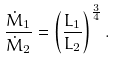<formula> <loc_0><loc_0><loc_500><loc_500>\frac { \dot { M } _ { 1 } } { \dot { M } _ { 2 } } = \left ( \frac { L _ { 1 } } { L _ { 2 } } \right ) ^ { \frac { 3 } { 4 } } .</formula> 